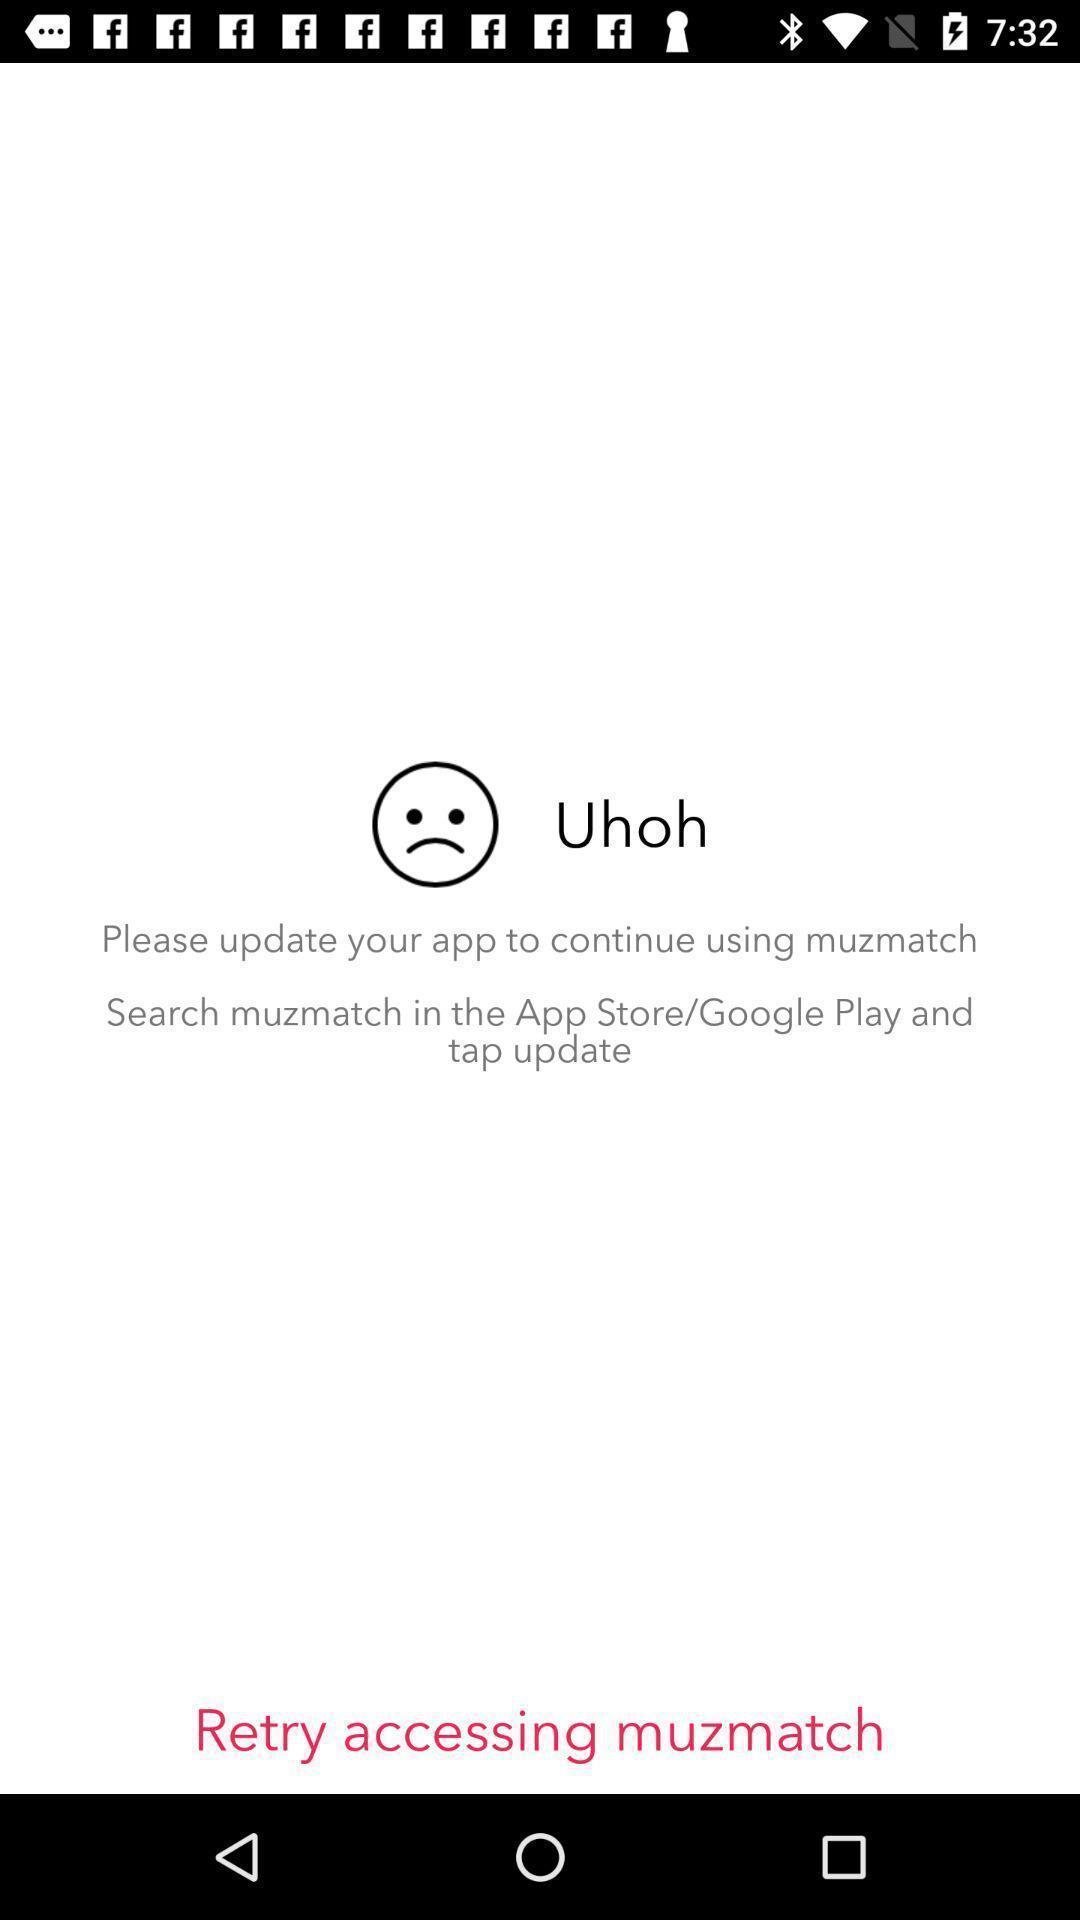Summarize the information in this screenshot. Page recommending to update the application. 